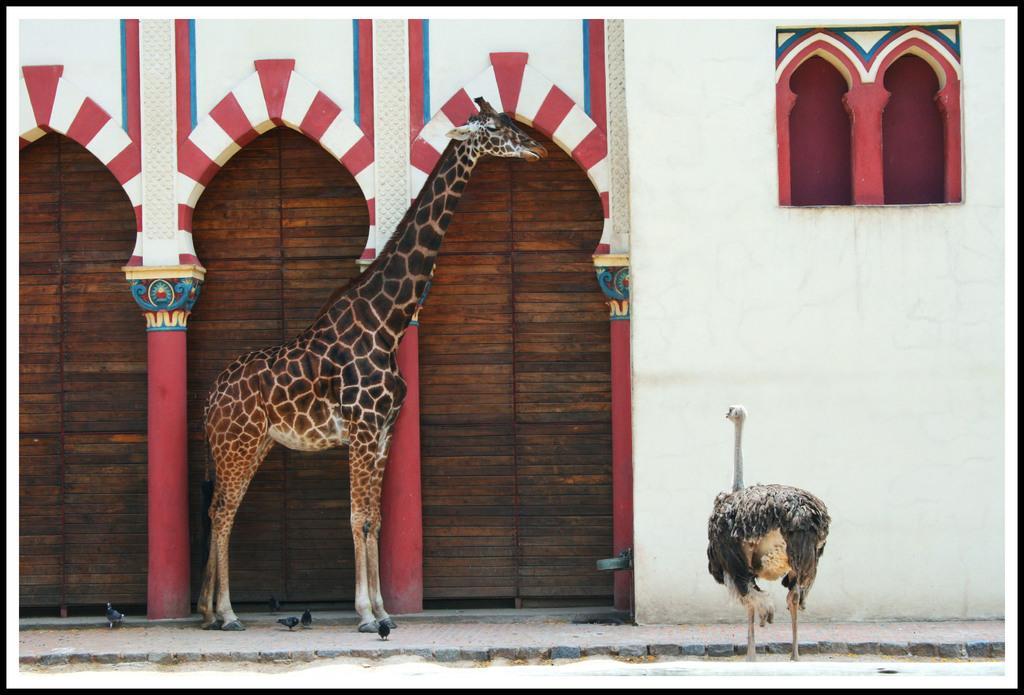Describe this image in one or two sentences. In this image, I can see a giraffe and an ostrich standing. This looks like a building. I think these are the wooden doors. I can see the small birds. 